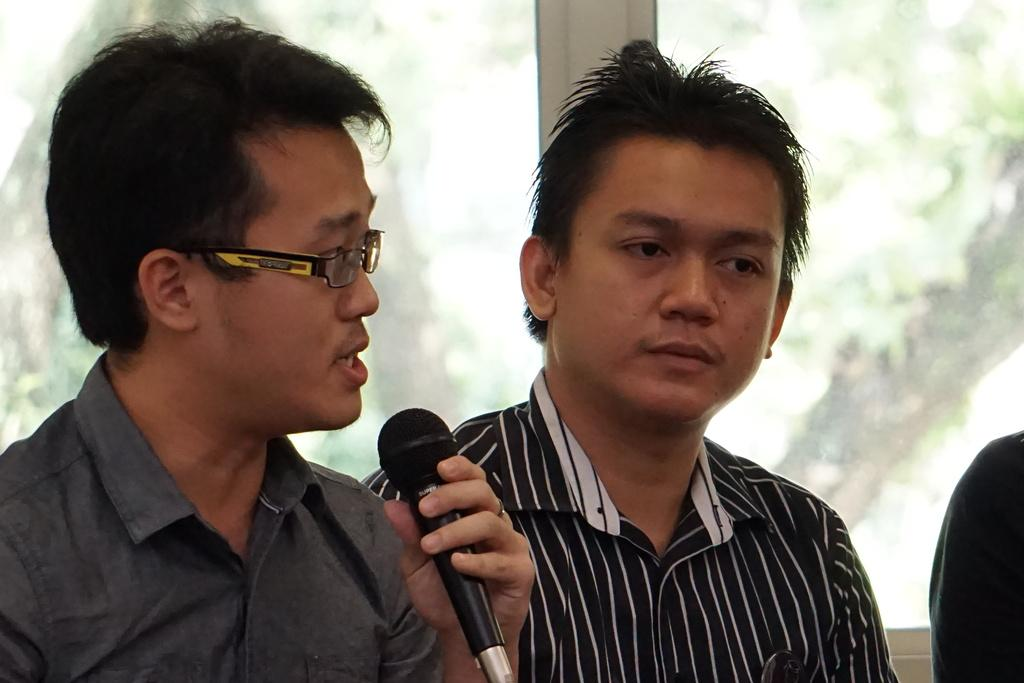How many people are in the image? There are two persons in the image. What is one person doing in the image? One person is holding a microphone. Can you describe anything visible in the background of the image? Yes, there is a glass visible in the background of the image. What type of board is being used to generate heat in the image? There is no board or heat generation present in the image. What type of work is being done by the person holding the microphone in the image? The image does not provide enough information to determine the type of work being done by the person holding the microphone. 